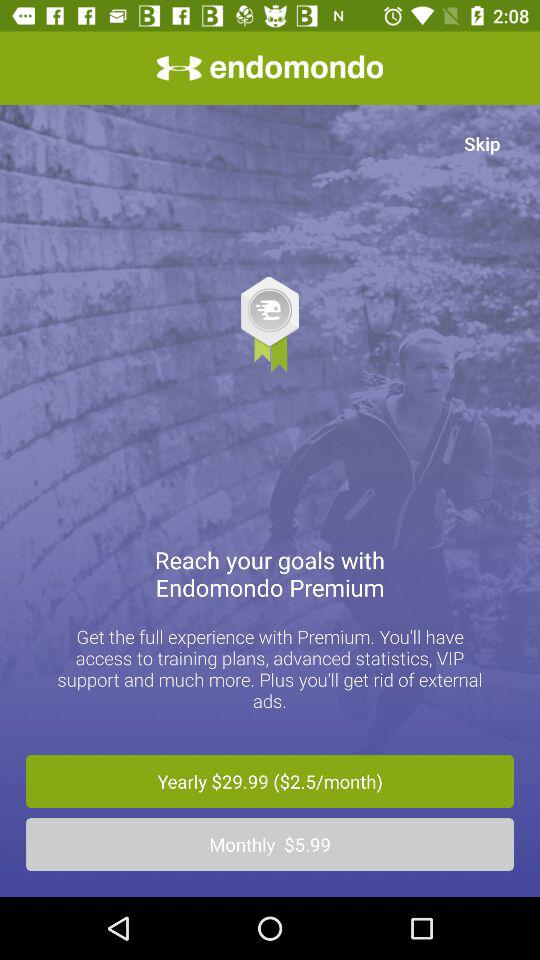How to pronounce the app name?
When the provided information is insufficient, respond with <no answer>. <no answer> 